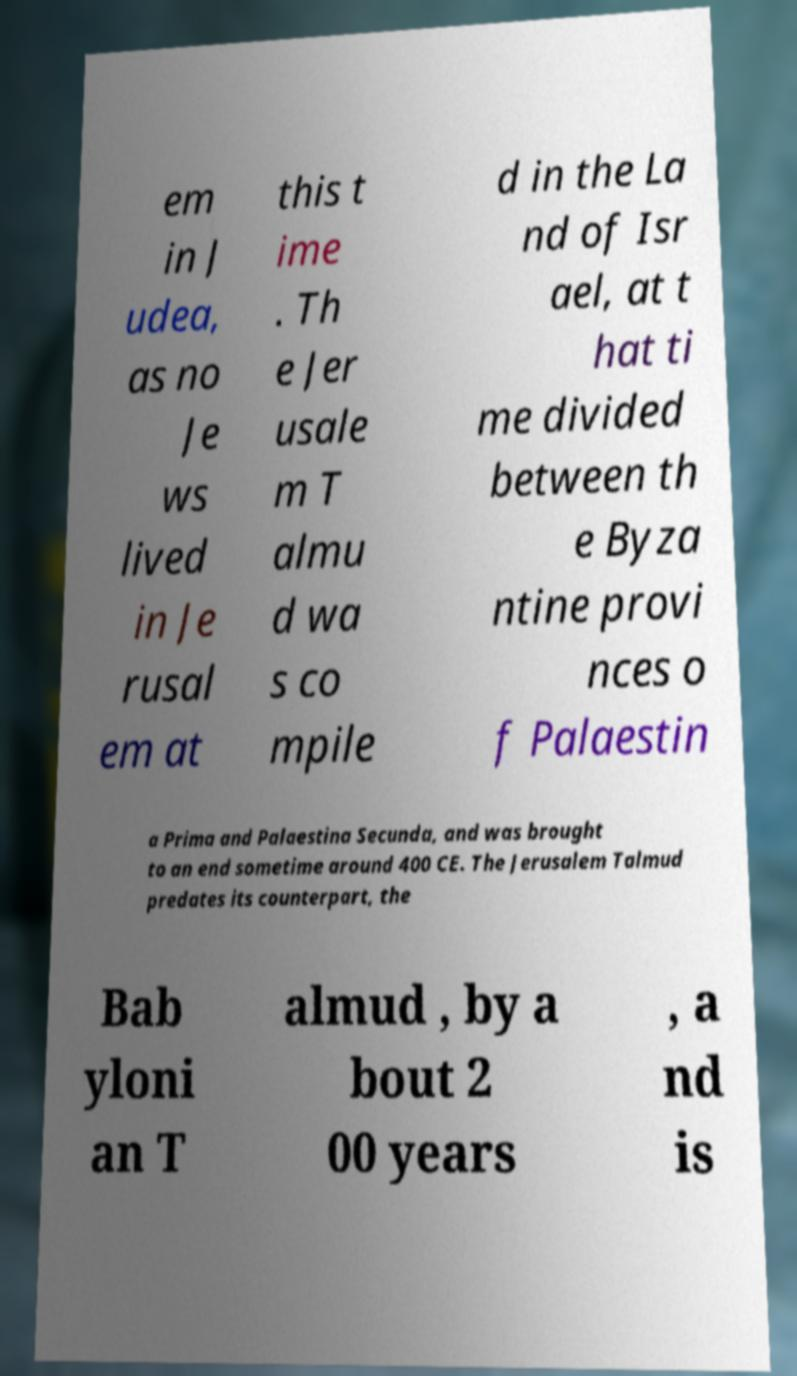I need the written content from this picture converted into text. Can you do that? em in J udea, as no Je ws lived in Je rusal em at this t ime . Th e Jer usale m T almu d wa s co mpile d in the La nd of Isr ael, at t hat ti me divided between th e Byza ntine provi nces o f Palaestin a Prima and Palaestina Secunda, and was brought to an end sometime around 400 CE. The Jerusalem Talmud predates its counterpart, the Bab yloni an T almud , by a bout 2 00 years , a nd is 